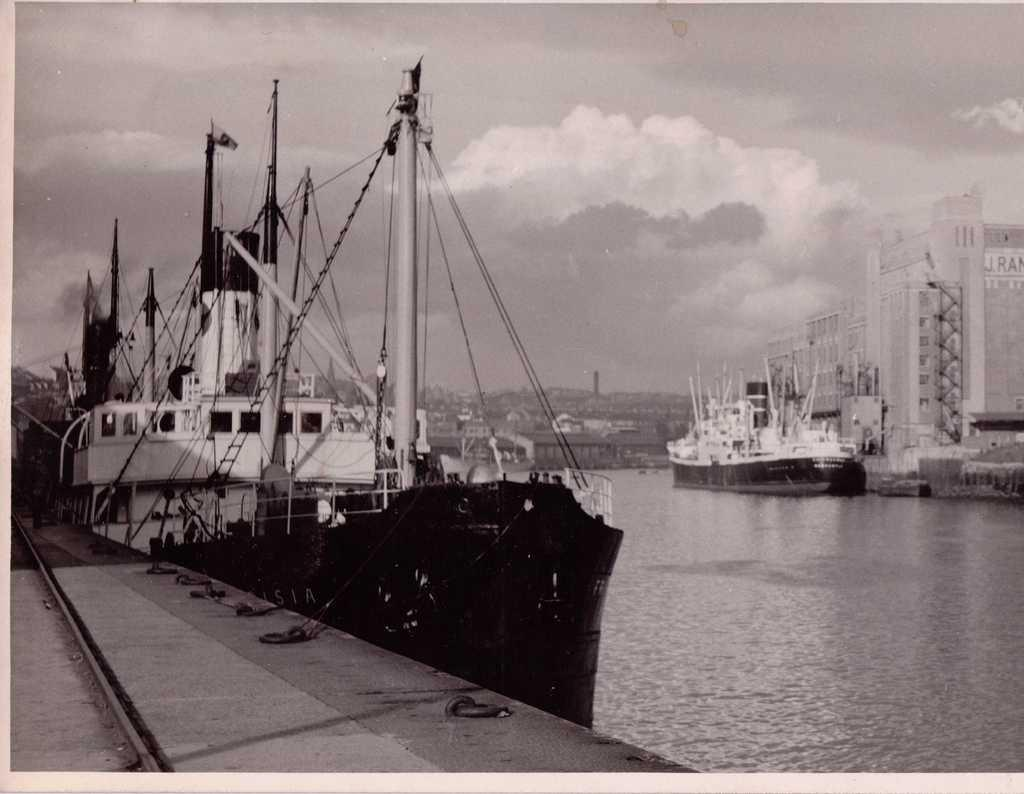What type of animals can be seen in the image? Birds can be seen in the image. What type of structure is visible in the image? There is a building in the image. What natural element is visible in the image? Water is visible in the image. What part of the natural environment is visible in the image? The sky is visible in the image. What can be seen in the sky in the image? There are clouds in the image. What is the weight of the pail in the image? There is no pail present in the image, so it is not possible to determine its weight. 